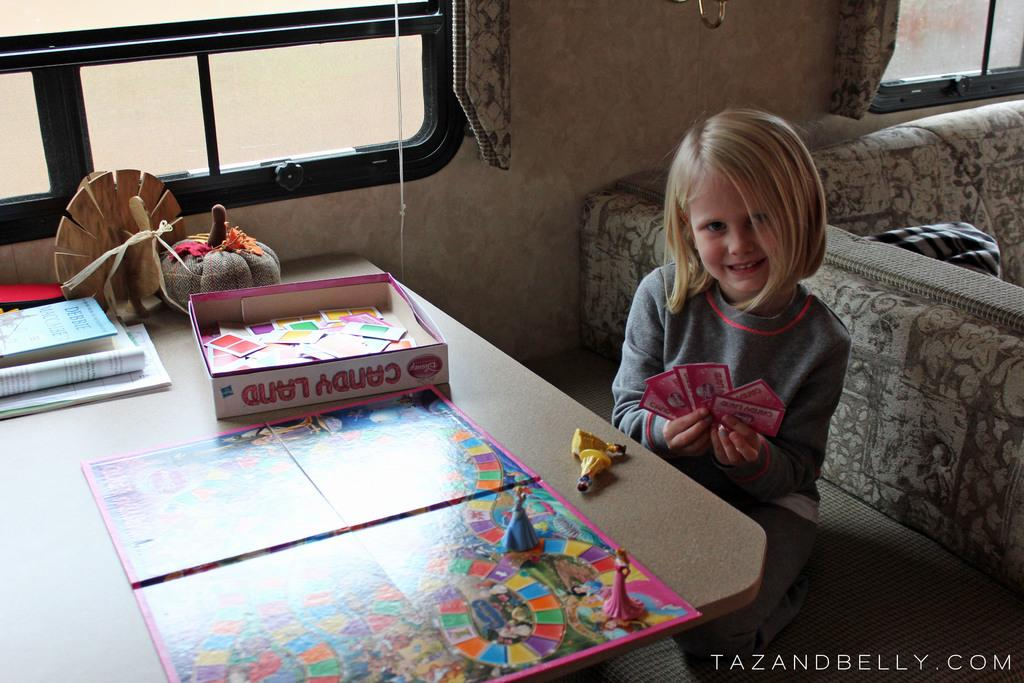<image>
Share a concise interpretation of the image provided. A girl playing candyland inside of a camper, ath the table. 